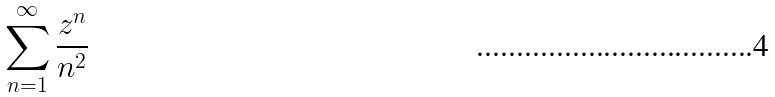<formula> <loc_0><loc_0><loc_500><loc_500>\sum _ { n = 1 } ^ { \infty } \frac { z ^ { n } } { n ^ { 2 } }</formula> 